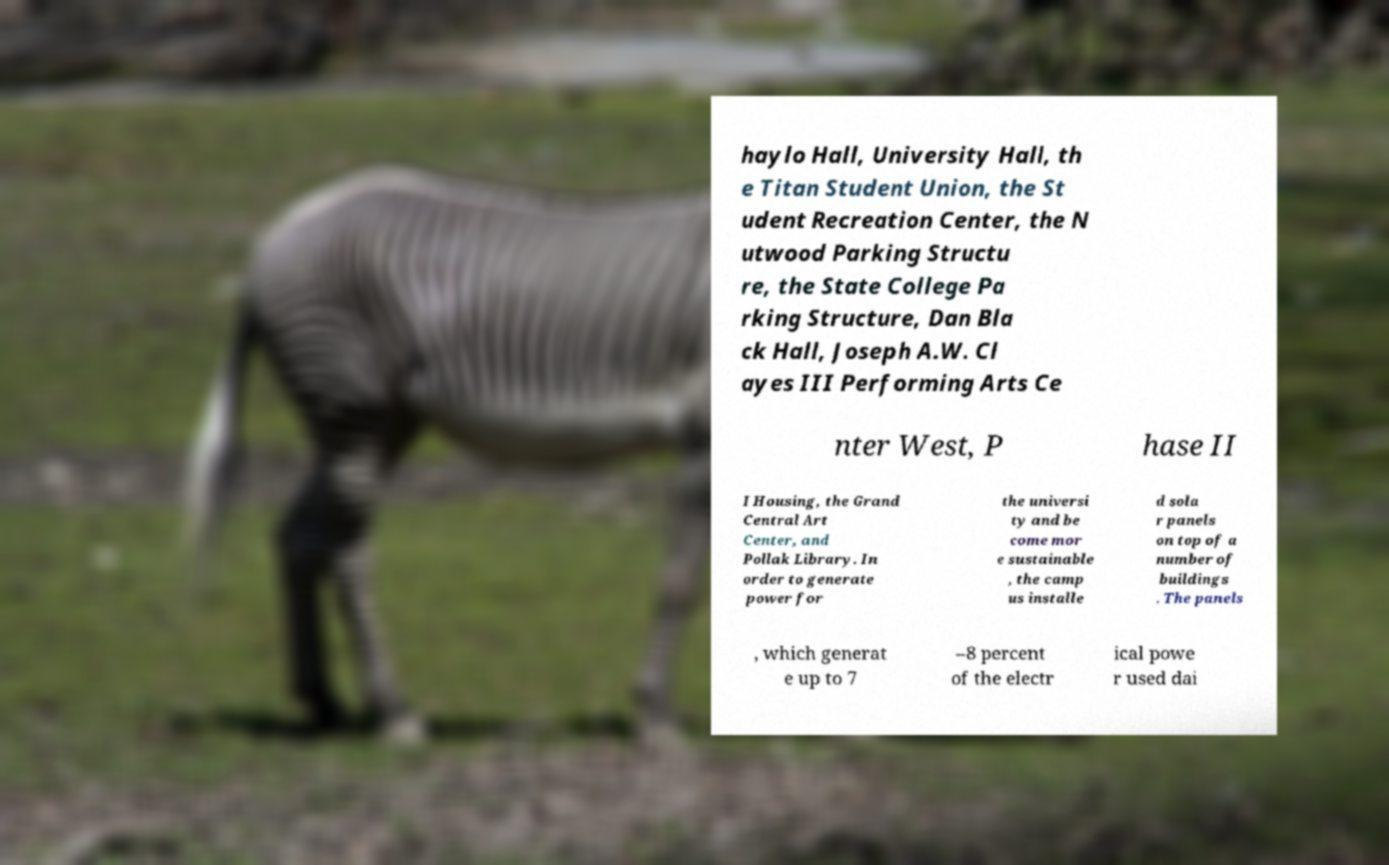There's text embedded in this image that I need extracted. Can you transcribe it verbatim? haylo Hall, University Hall, th e Titan Student Union, the St udent Recreation Center, the N utwood Parking Structu re, the State College Pa rking Structure, Dan Bla ck Hall, Joseph A.W. Cl ayes III Performing Arts Ce nter West, P hase II I Housing, the Grand Central Art Center, and Pollak Library. In order to generate power for the universi ty and be come mor e sustainable , the camp us installe d sola r panels on top of a number of buildings . The panels , which generat e up to 7 –8 percent of the electr ical powe r used dai 